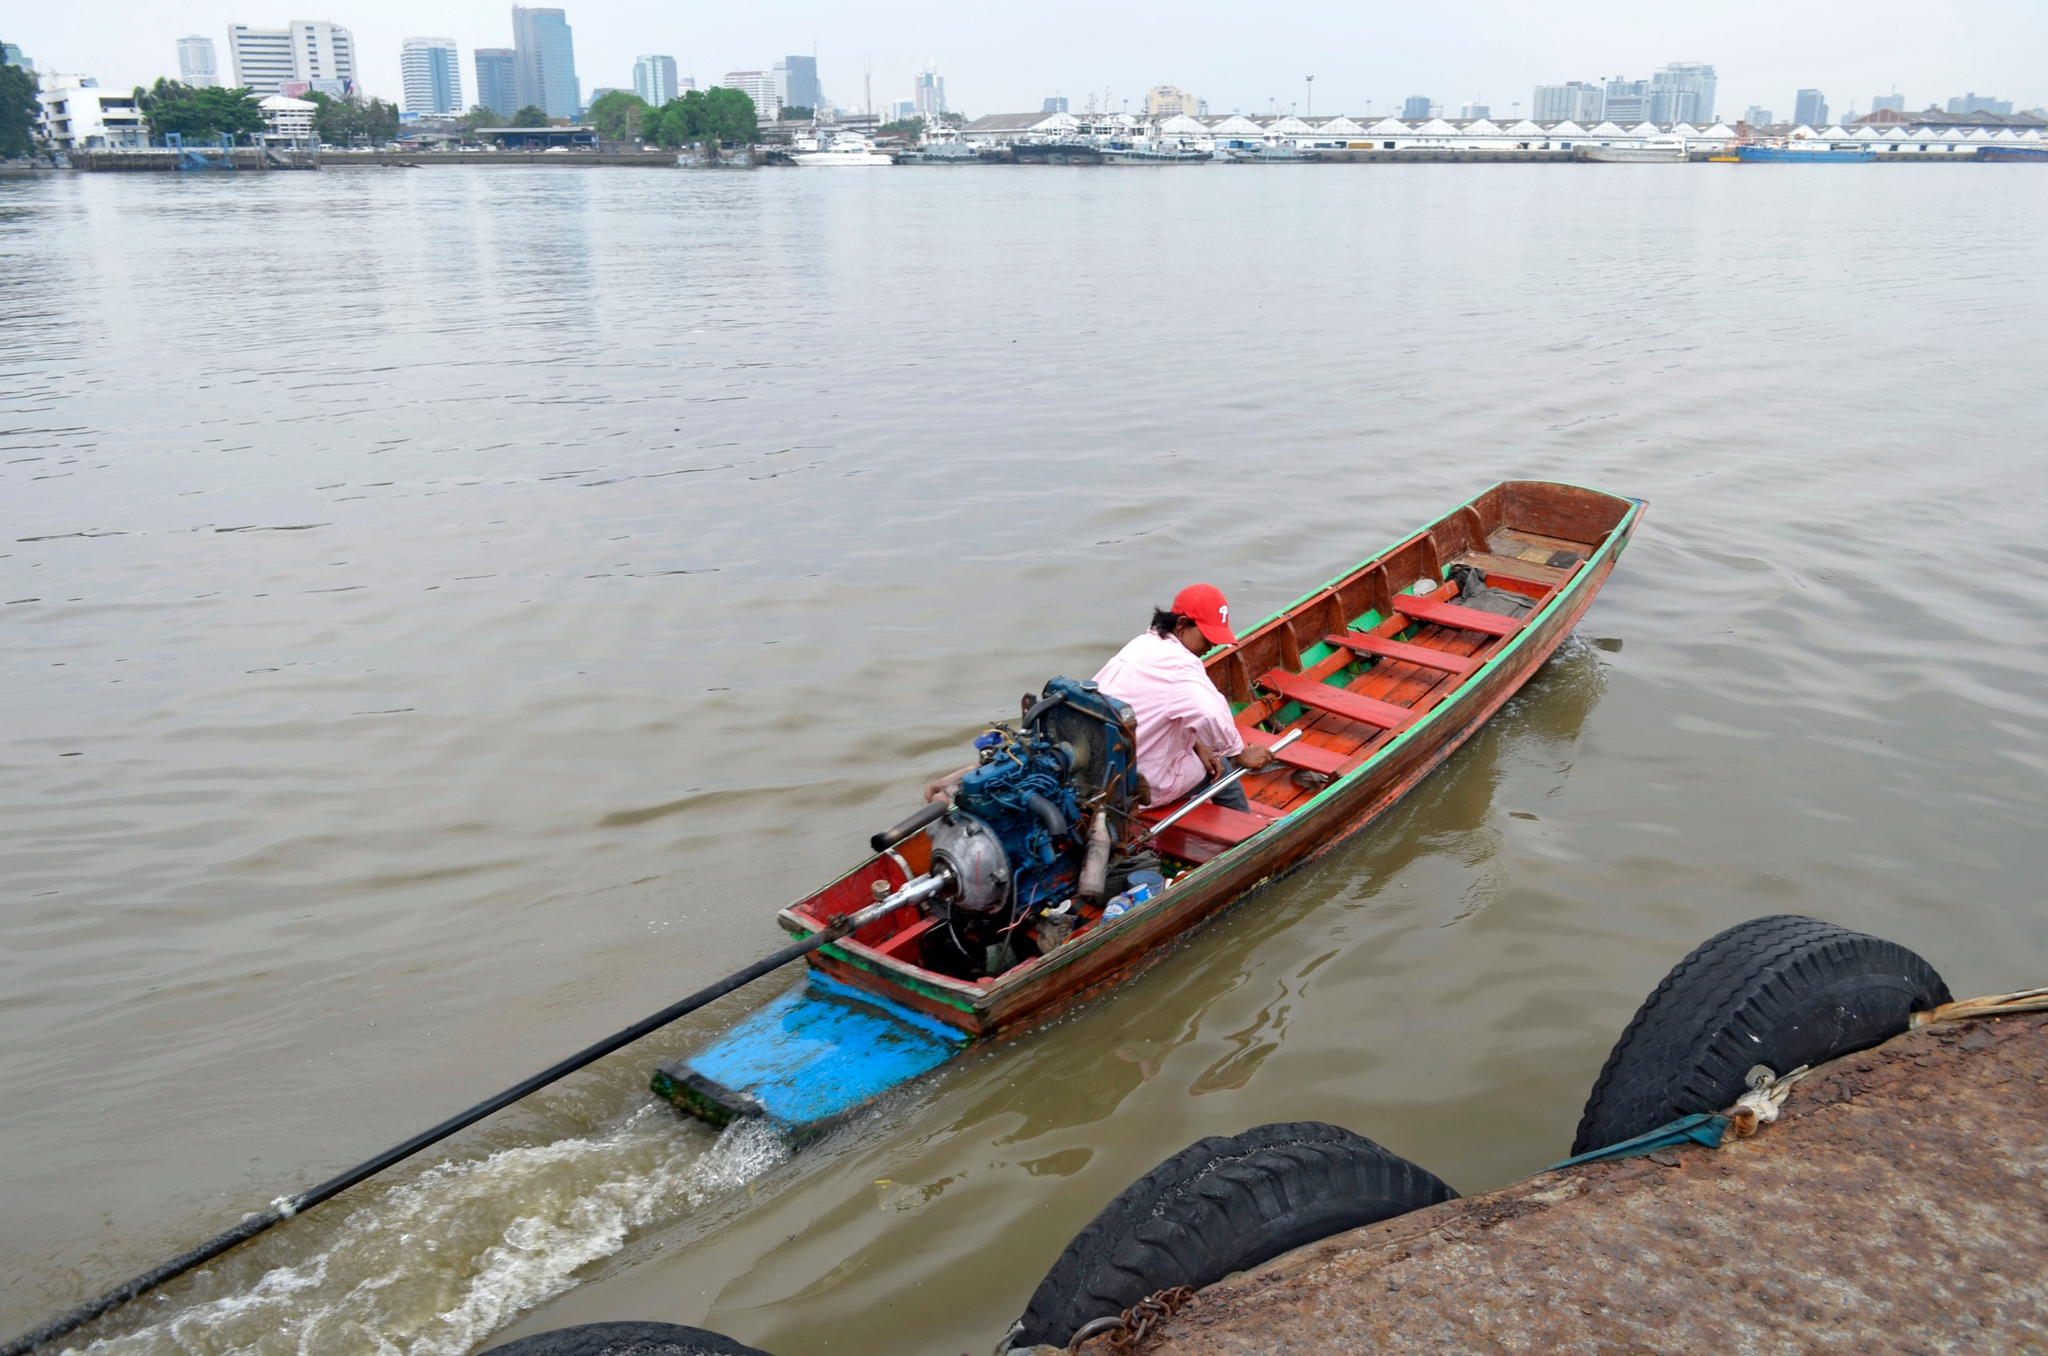Imagine the person in the boat is part of a magical world. What extraordinary things might they encounter on their journey? In a magical world, the person in the boat might encounter an array of extraordinary and fantastical elements. As they glide through the water, luminous fish with glowing fins could light up the river’s path, guiding their way forward. Enchanted water lilies might bloom as they approach, each flower opening to reveal tiny, shimmering fairies who sprinkle magical dust into the air.

Further along the journey, they might pass through a hidden portal in the river that transports them to an ethereal forest where trees have golden leaves and branches that whisper ancient secrets. Here, they might meet wise, talking animals or elves who guard the forest and offer mystical artifacts or wisdom for the journey ahead.

As night falls, the sky could transform into a celestial show with constellations coming to life, depicting stories of old. The moonlight might cause the water to sparkle like a mirror, revealing hidden pathways or mystical creatures swimming below. It’s a world where every turn of the river hides new wonders, from floating islands inhabited by mythical beings to underwater kingdoms ruled by merfolk. 